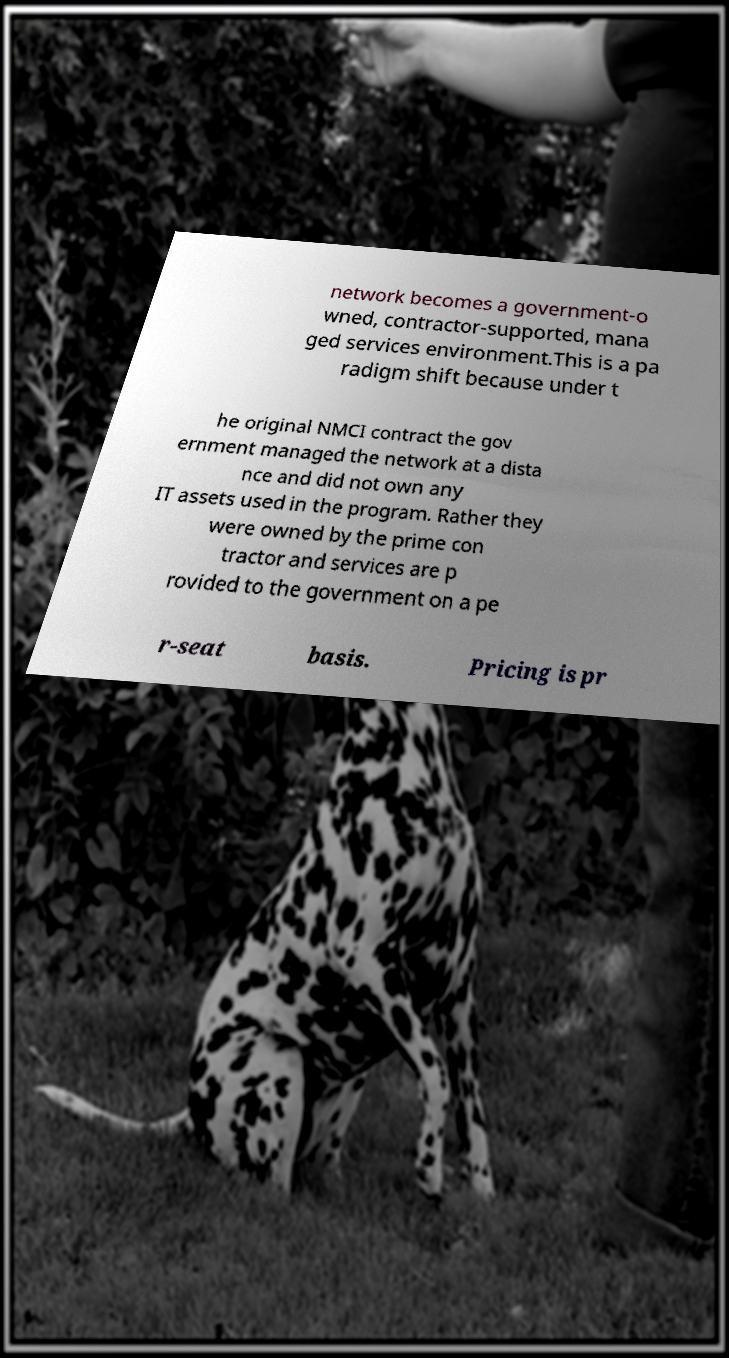I need the written content from this picture converted into text. Can you do that? network becomes a government-o wned, contractor-supported, mana ged services environment.This is a pa radigm shift because under t he original NMCI contract the gov ernment managed the network at a dista nce and did not own any IT assets used in the program. Rather they were owned by the prime con tractor and services are p rovided to the government on a pe r-seat basis. Pricing is pr 